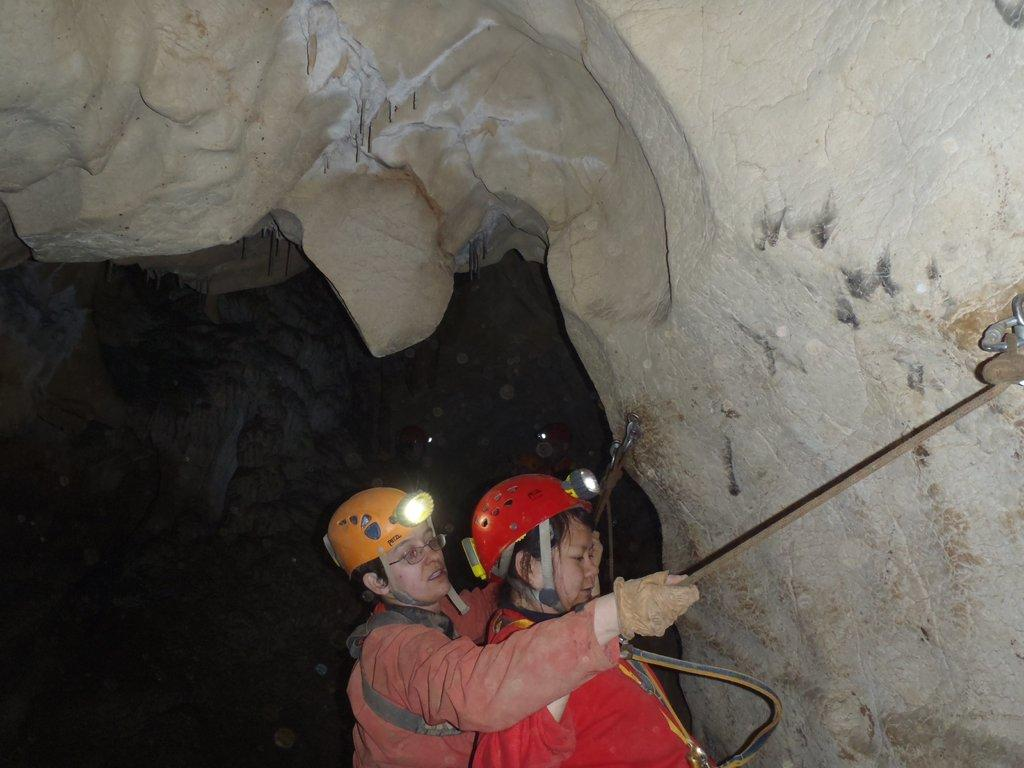What type of natural formation is present in the image? There is a rock cave in the image. Who is near the rock cave? Two persons are near the rock cave. What are the persons holding? The persons are holding a rope. What type of clothing are the persons wearing? The persons are wearing jackets and helmets. What additional equipment do the persons have? The persons have lights. Can you see any goats nesting in the rock cave in the image? There are no goats or nests present in the image; it features a rock cave with two persons near it. 